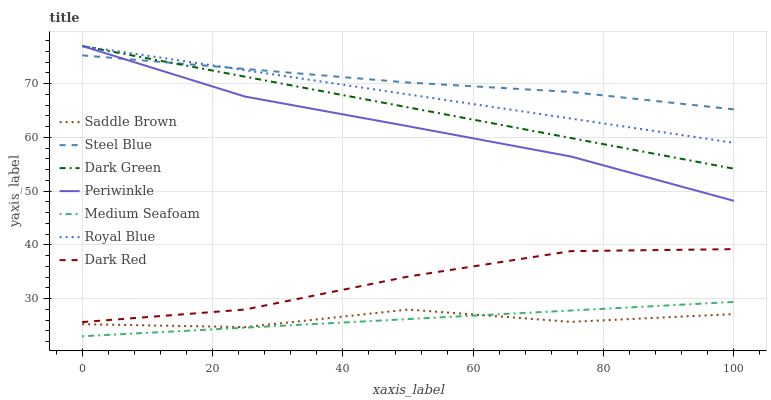Does Saddle Brown have the minimum area under the curve?
Answer yes or no. Yes. Does Steel Blue have the maximum area under the curve?
Answer yes or no. Yes. Does Steel Blue have the minimum area under the curve?
Answer yes or no. No. Does Saddle Brown have the maximum area under the curve?
Answer yes or no. No. Is Medium Seafoam the smoothest?
Answer yes or no. Yes. Is Saddle Brown the roughest?
Answer yes or no. Yes. Is Steel Blue the smoothest?
Answer yes or no. No. Is Steel Blue the roughest?
Answer yes or no. No. Does Medium Seafoam have the lowest value?
Answer yes or no. Yes. Does Saddle Brown have the lowest value?
Answer yes or no. No. Does Dark Green have the highest value?
Answer yes or no. Yes. Does Steel Blue have the highest value?
Answer yes or no. No. Is Medium Seafoam less than Periwinkle?
Answer yes or no. Yes. Is Royal Blue greater than Dark Red?
Answer yes or no. Yes. Does Dark Green intersect Royal Blue?
Answer yes or no. Yes. Is Dark Green less than Royal Blue?
Answer yes or no. No. Is Dark Green greater than Royal Blue?
Answer yes or no. No. Does Medium Seafoam intersect Periwinkle?
Answer yes or no. No. 